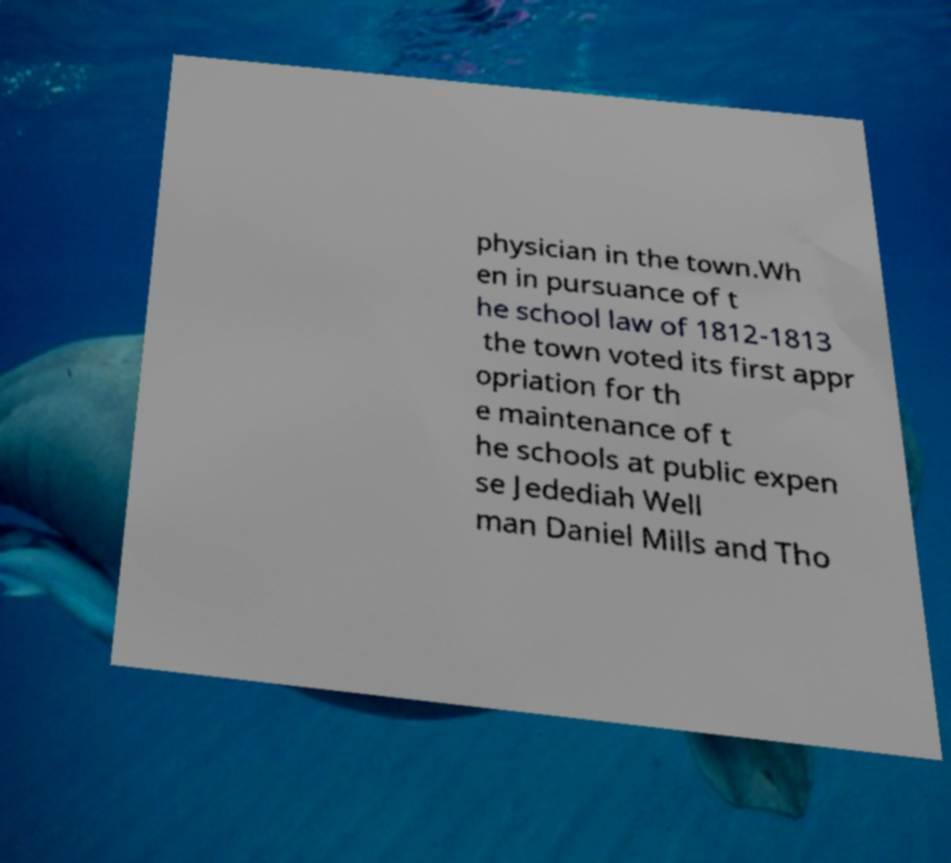I need the written content from this picture converted into text. Can you do that? physician in the town.Wh en in pursuance of t he school law of 1812-1813 the town voted its first appr opriation for th e maintenance of t he schools at public expen se Jedediah Well man Daniel Mills and Tho 